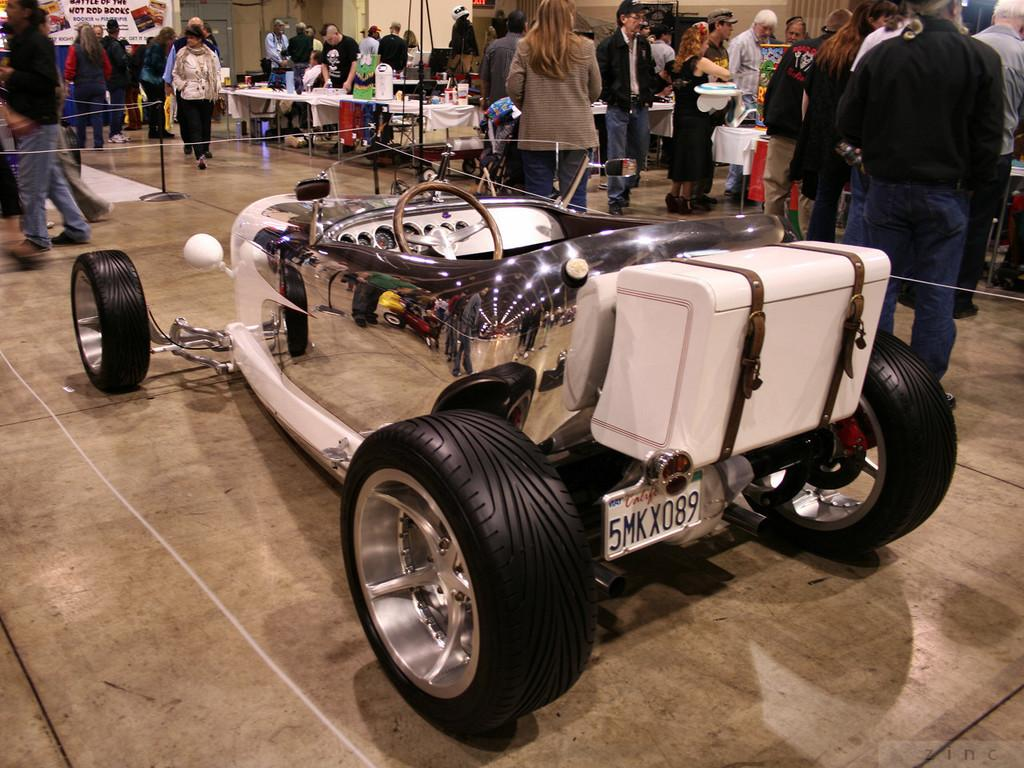What is the main subject in the image? There is a vehicle in the image. What can be seen in the background of the image? There are people, tables, and other objects in the background of the image. What is visible at the bottom of the image? The floor is visible at the bottom of the image. What type of teeth can be seen on the vehicle in the image? There are no teeth present on the vehicle in the image. 